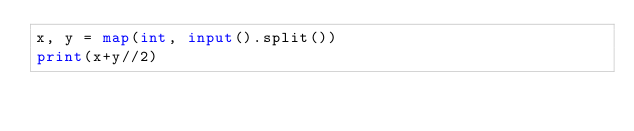Convert code to text. <code><loc_0><loc_0><loc_500><loc_500><_Python_>x, y = map(int, input().split())
print(x+y//2)
</code> 